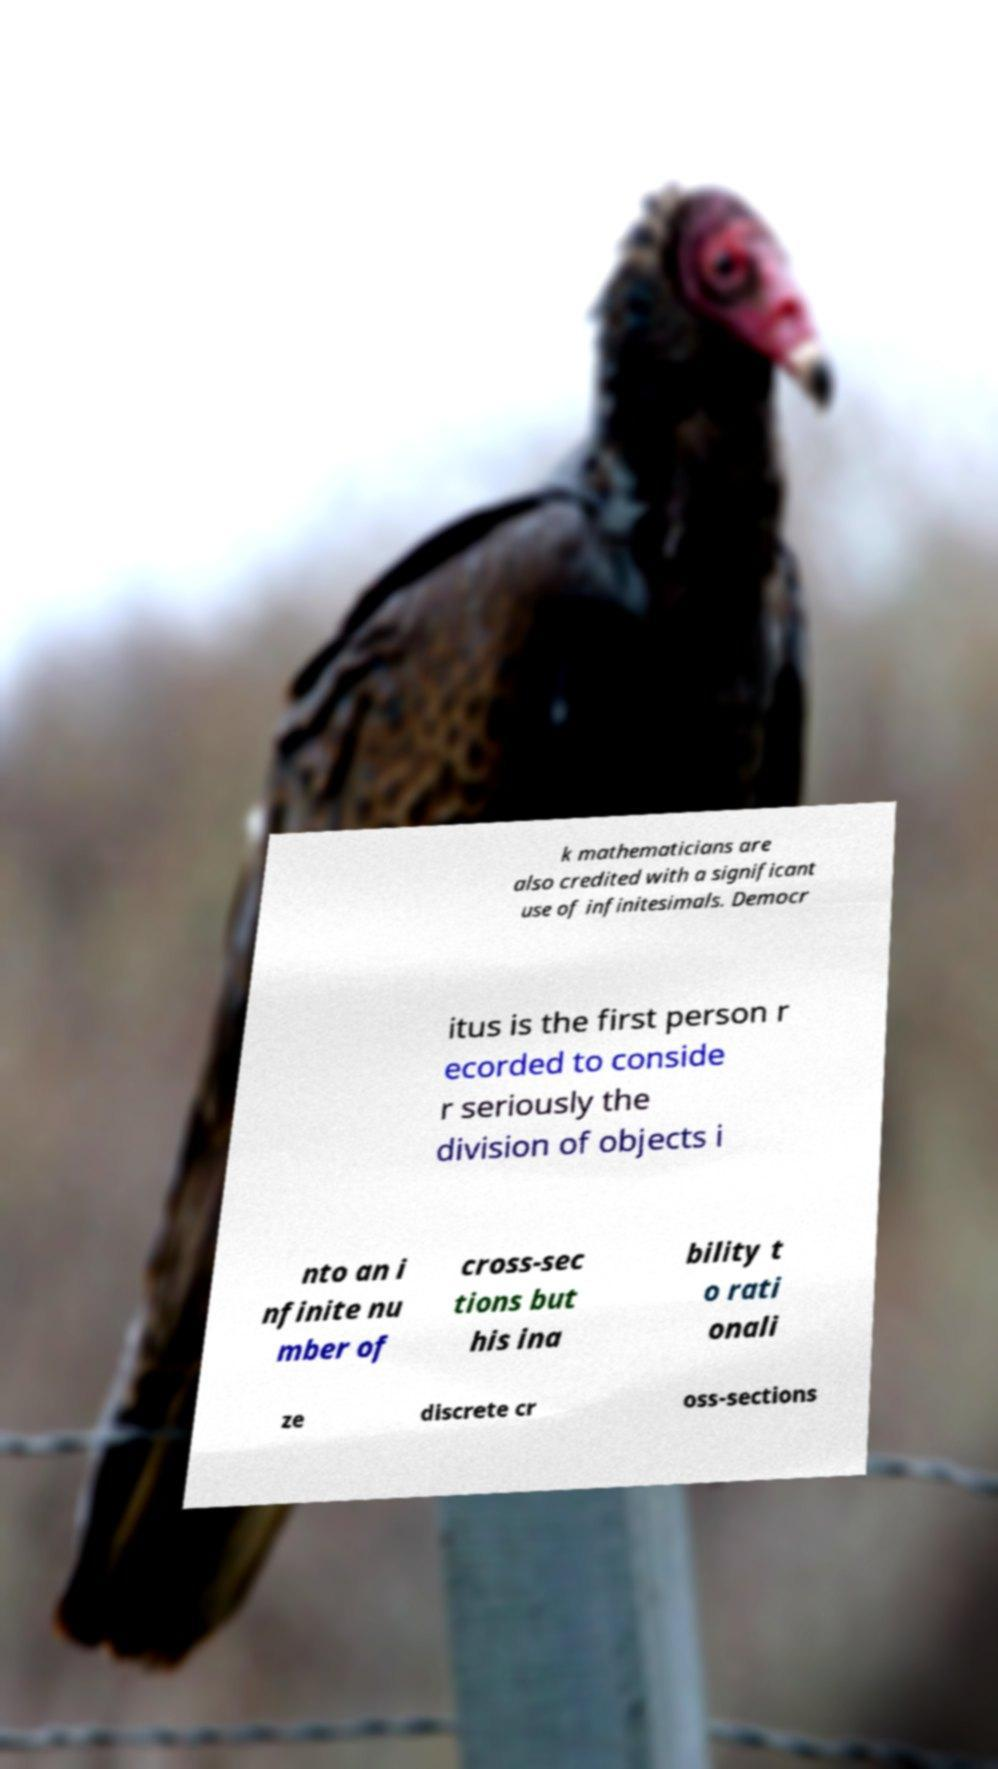I need the written content from this picture converted into text. Can you do that? k mathematicians are also credited with a significant use of infinitesimals. Democr itus is the first person r ecorded to conside r seriously the division of objects i nto an i nfinite nu mber of cross-sec tions but his ina bility t o rati onali ze discrete cr oss-sections 